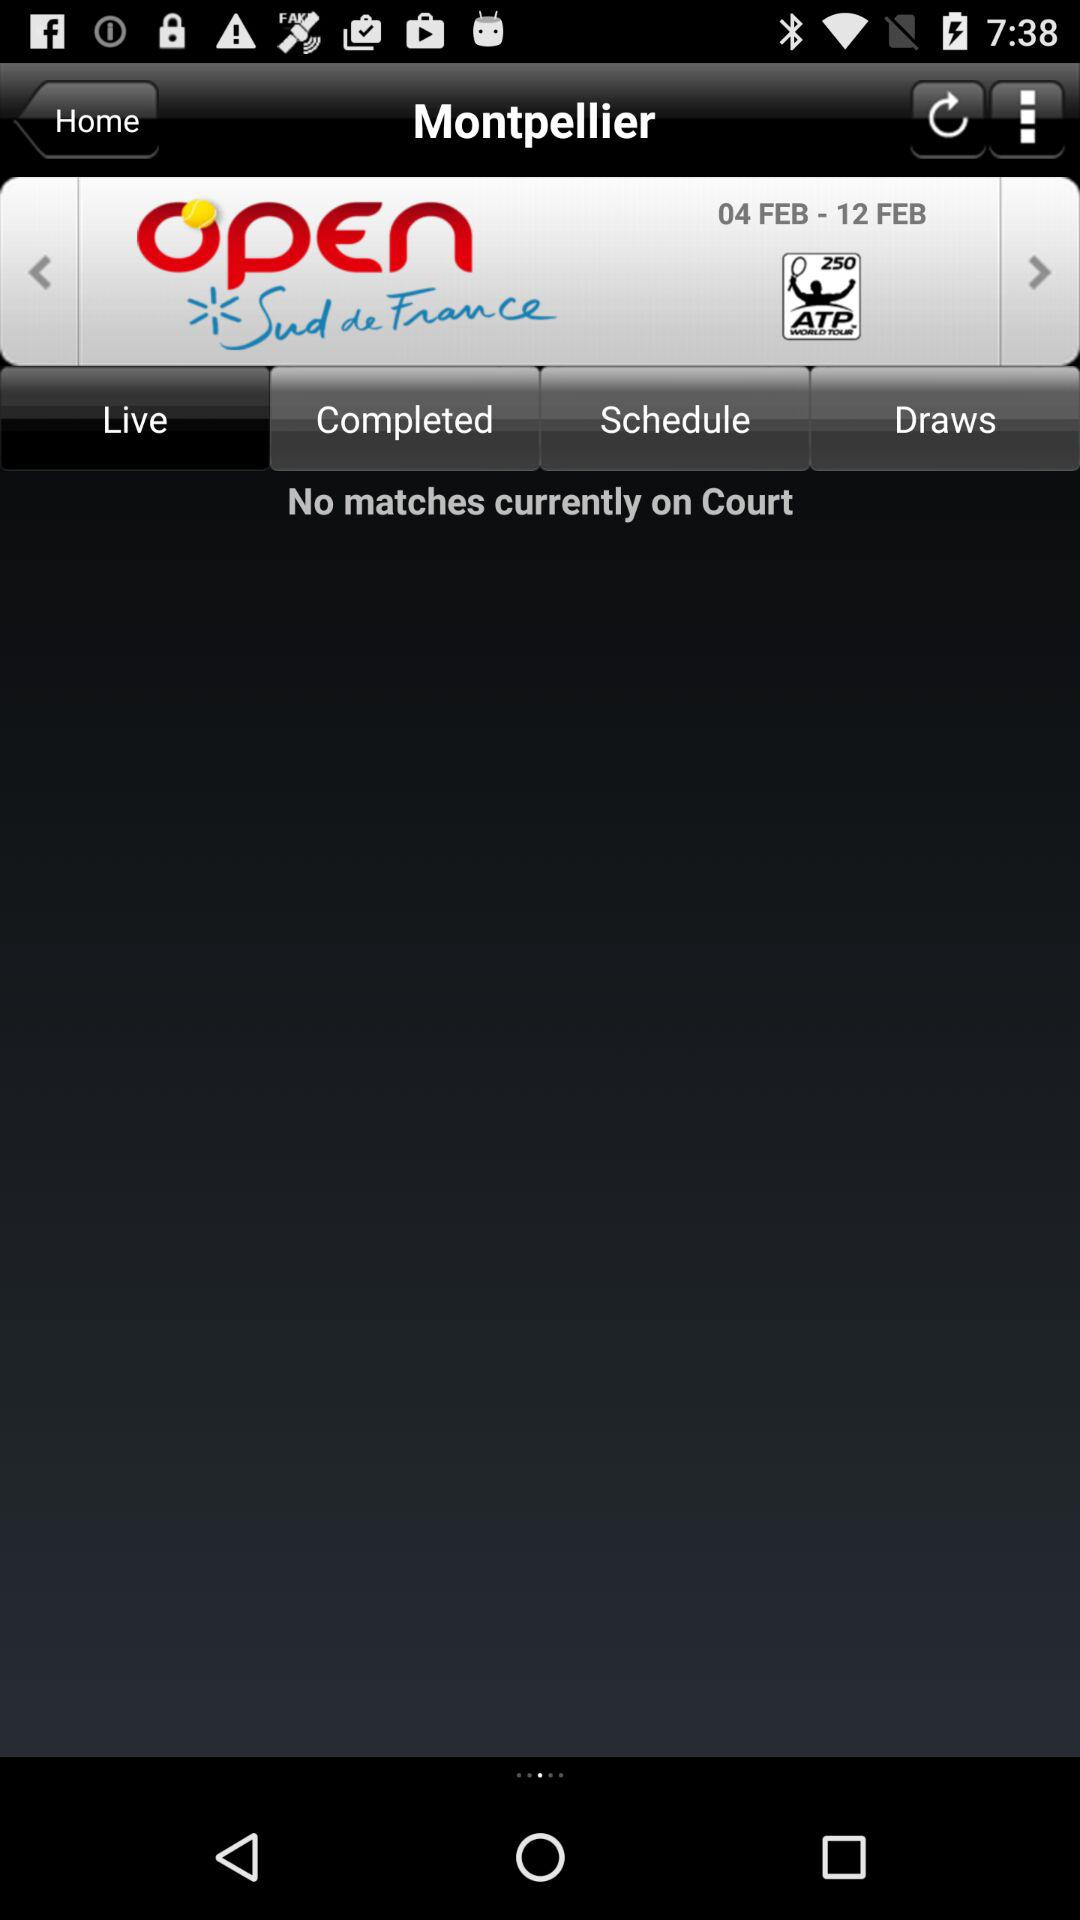What is the selected tab? The selected tab is "Live". 